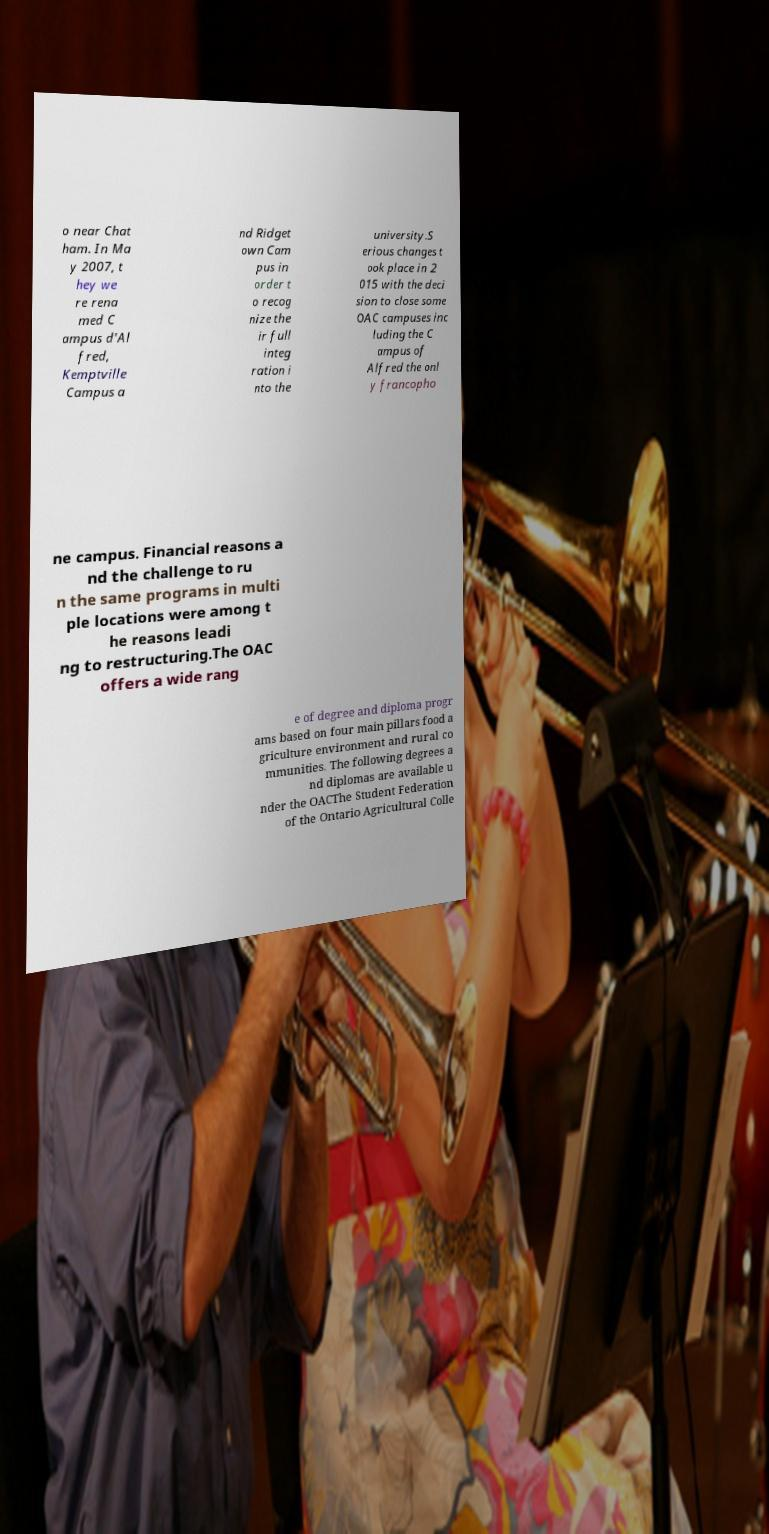I need the written content from this picture converted into text. Can you do that? o near Chat ham. In Ma y 2007, t hey we re rena med C ampus d'Al fred, Kemptville Campus a nd Ridget own Cam pus in order t o recog nize the ir full integ ration i nto the university.S erious changes t ook place in 2 015 with the deci sion to close some OAC campuses inc luding the C ampus of Alfred the onl y francopho ne campus. Financial reasons a nd the challenge to ru n the same programs in multi ple locations were among t he reasons leadi ng to restructuring.The OAC offers a wide rang e of degree and diploma progr ams based on four main pillars food a griculture environment and rural co mmunities. The following degrees a nd diplomas are available u nder the OACThe Student Federation of the Ontario Agricultural Colle 